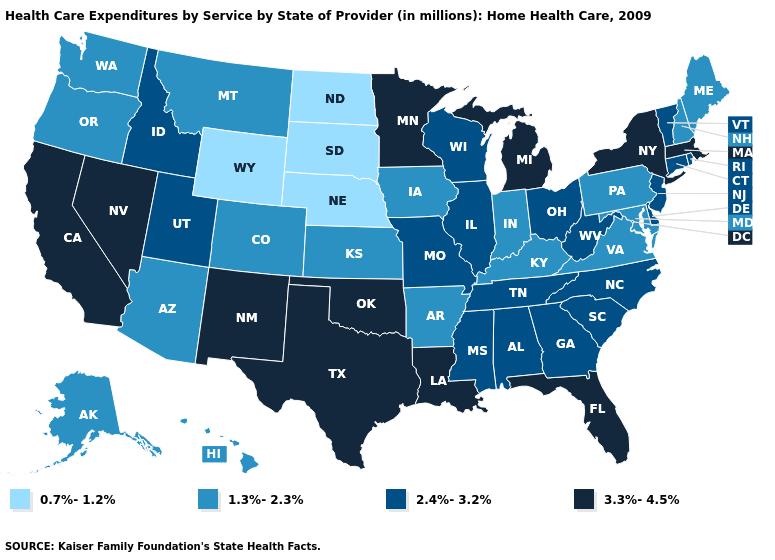What is the highest value in states that border Louisiana?
Write a very short answer. 3.3%-4.5%. Name the states that have a value in the range 1.3%-2.3%?
Concise answer only. Alaska, Arizona, Arkansas, Colorado, Hawaii, Indiana, Iowa, Kansas, Kentucky, Maine, Maryland, Montana, New Hampshire, Oregon, Pennsylvania, Virginia, Washington. Name the states that have a value in the range 2.4%-3.2%?
Be succinct. Alabama, Connecticut, Delaware, Georgia, Idaho, Illinois, Mississippi, Missouri, New Jersey, North Carolina, Ohio, Rhode Island, South Carolina, Tennessee, Utah, Vermont, West Virginia, Wisconsin. Name the states that have a value in the range 0.7%-1.2%?
Give a very brief answer. Nebraska, North Dakota, South Dakota, Wyoming. What is the highest value in states that border North Dakota?
Give a very brief answer. 3.3%-4.5%. What is the highest value in states that border Virginia?
Write a very short answer. 2.4%-3.2%. Name the states that have a value in the range 0.7%-1.2%?
Give a very brief answer. Nebraska, North Dakota, South Dakota, Wyoming. Which states have the lowest value in the Northeast?
Keep it brief. Maine, New Hampshire, Pennsylvania. Does the first symbol in the legend represent the smallest category?
Quick response, please. Yes. Among the states that border South Dakota , which have the highest value?
Be succinct. Minnesota. What is the value of Mississippi?
Give a very brief answer. 2.4%-3.2%. What is the highest value in the South ?
Give a very brief answer. 3.3%-4.5%. Name the states that have a value in the range 0.7%-1.2%?
Be succinct. Nebraska, North Dakota, South Dakota, Wyoming. Does the map have missing data?
Write a very short answer. No. 